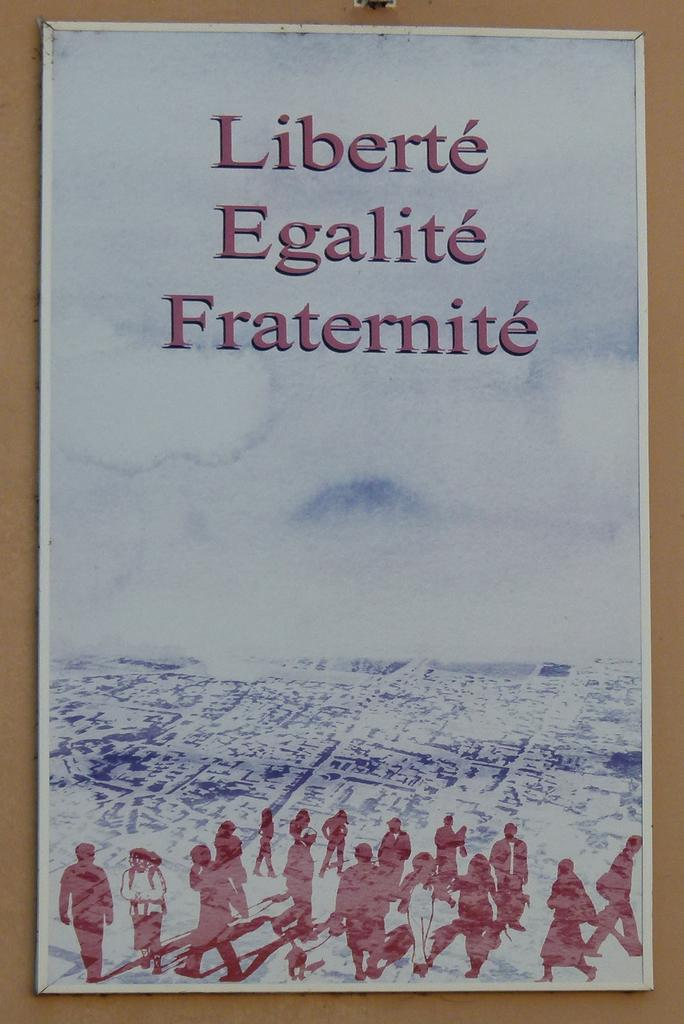Provide a one-sentence caption for the provided image. A poster that says Liberte, Egalite and Fraternite. 